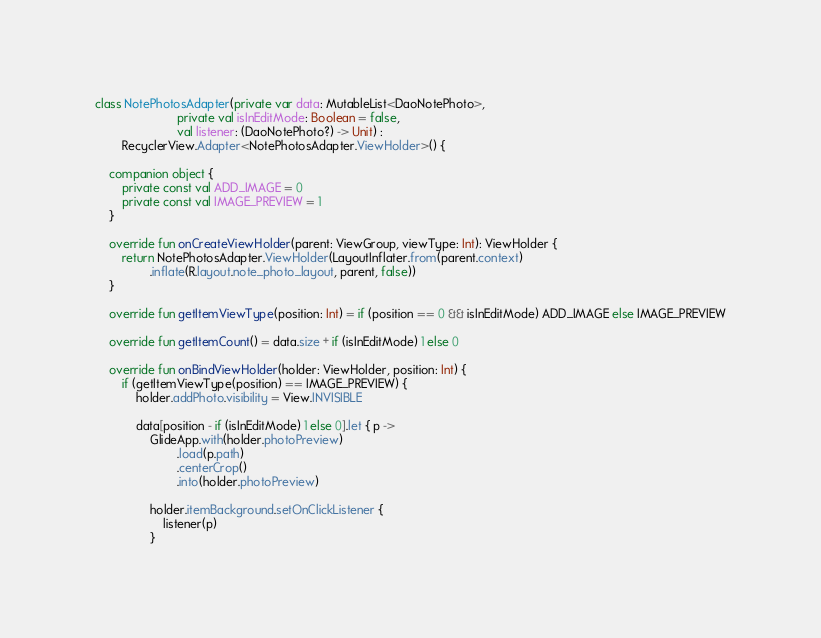Convert code to text. <code><loc_0><loc_0><loc_500><loc_500><_Kotlin_>
class NotePhotosAdapter(private var data: MutableList<DaoNotePhoto>,
                        private val isInEditMode: Boolean = false,
                        val listener: (DaoNotePhoto?) -> Unit) :
        RecyclerView.Adapter<NotePhotosAdapter.ViewHolder>() {

    companion object {
        private const val ADD_IMAGE = 0
        private const val IMAGE_PREVIEW = 1
    }

    override fun onCreateViewHolder(parent: ViewGroup, viewType: Int): ViewHolder {
        return NotePhotosAdapter.ViewHolder(LayoutInflater.from(parent.context)
                .inflate(R.layout.note_photo_layout, parent, false))
    }

    override fun getItemViewType(position: Int) = if (position == 0 && isInEditMode) ADD_IMAGE else IMAGE_PREVIEW

    override fun getItemCount() = data.size + if (isInEditMode) 1 else 0

    override fun onBindViewHolder(holder: ViewHolder, position: Int) {
        if (getItemViewType(position) == IMAGE_PREVIEW) {
            holder.addPhoto.visibility = View.INVISIBLE

            data[position - if (isInEditMode) 1 else 0].let { p ->
                GlideApp.with(holder.photoPreview)
                        .load(p.path)
                        .centerCrop()
                        .into(holder.photoPreview)

                holder.itemBackground.setOnClickListener {
                    listener(p)
                }
</code> 